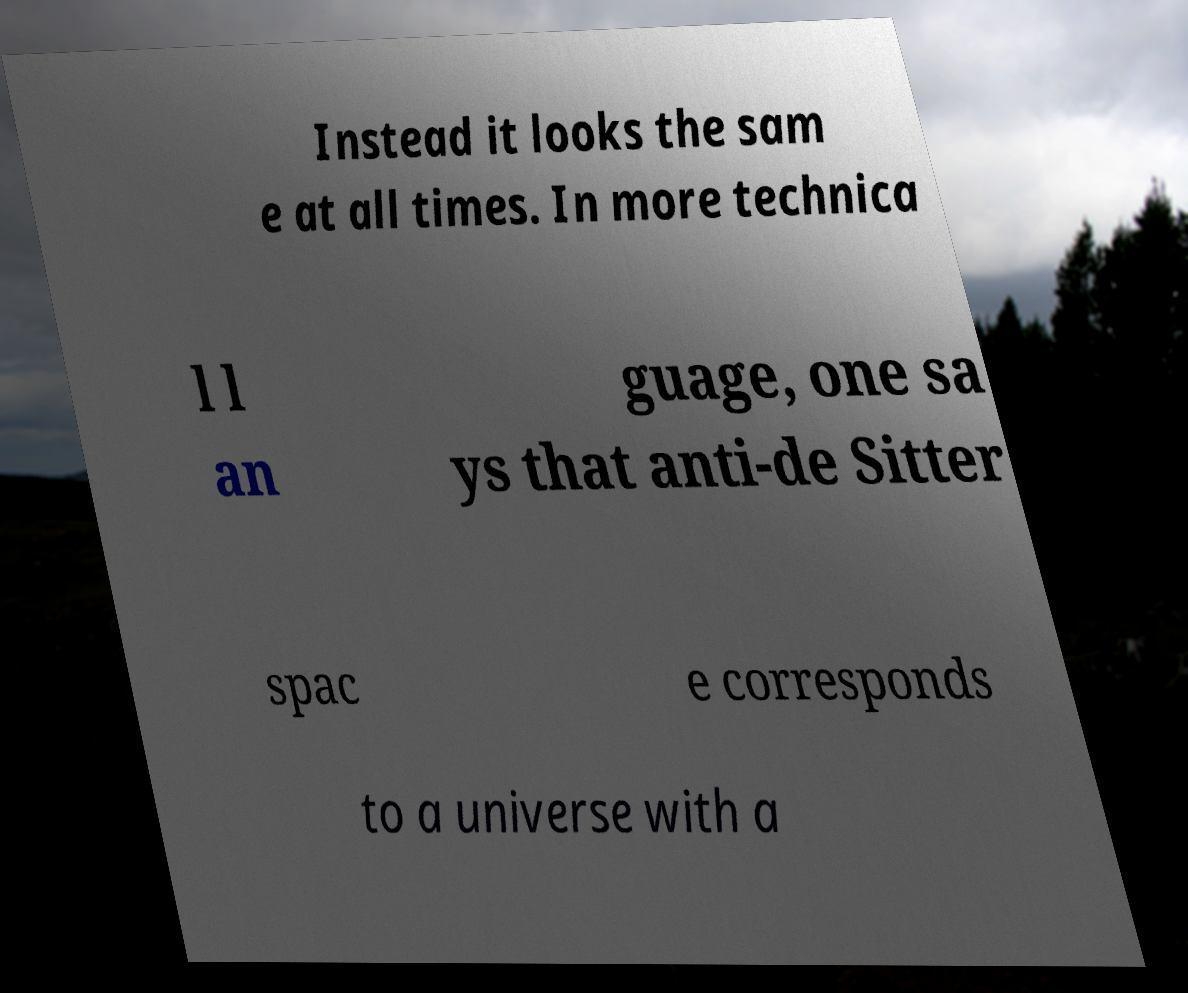Can you read and provide the text displayed in the image?This photo seems to have some interesting text. Can you extract and type it out for me? Instead it looks the sam e at all times. In more technica l l an guage, one sa ys that anti-de Sitter spac e corresponds to a universe with a 